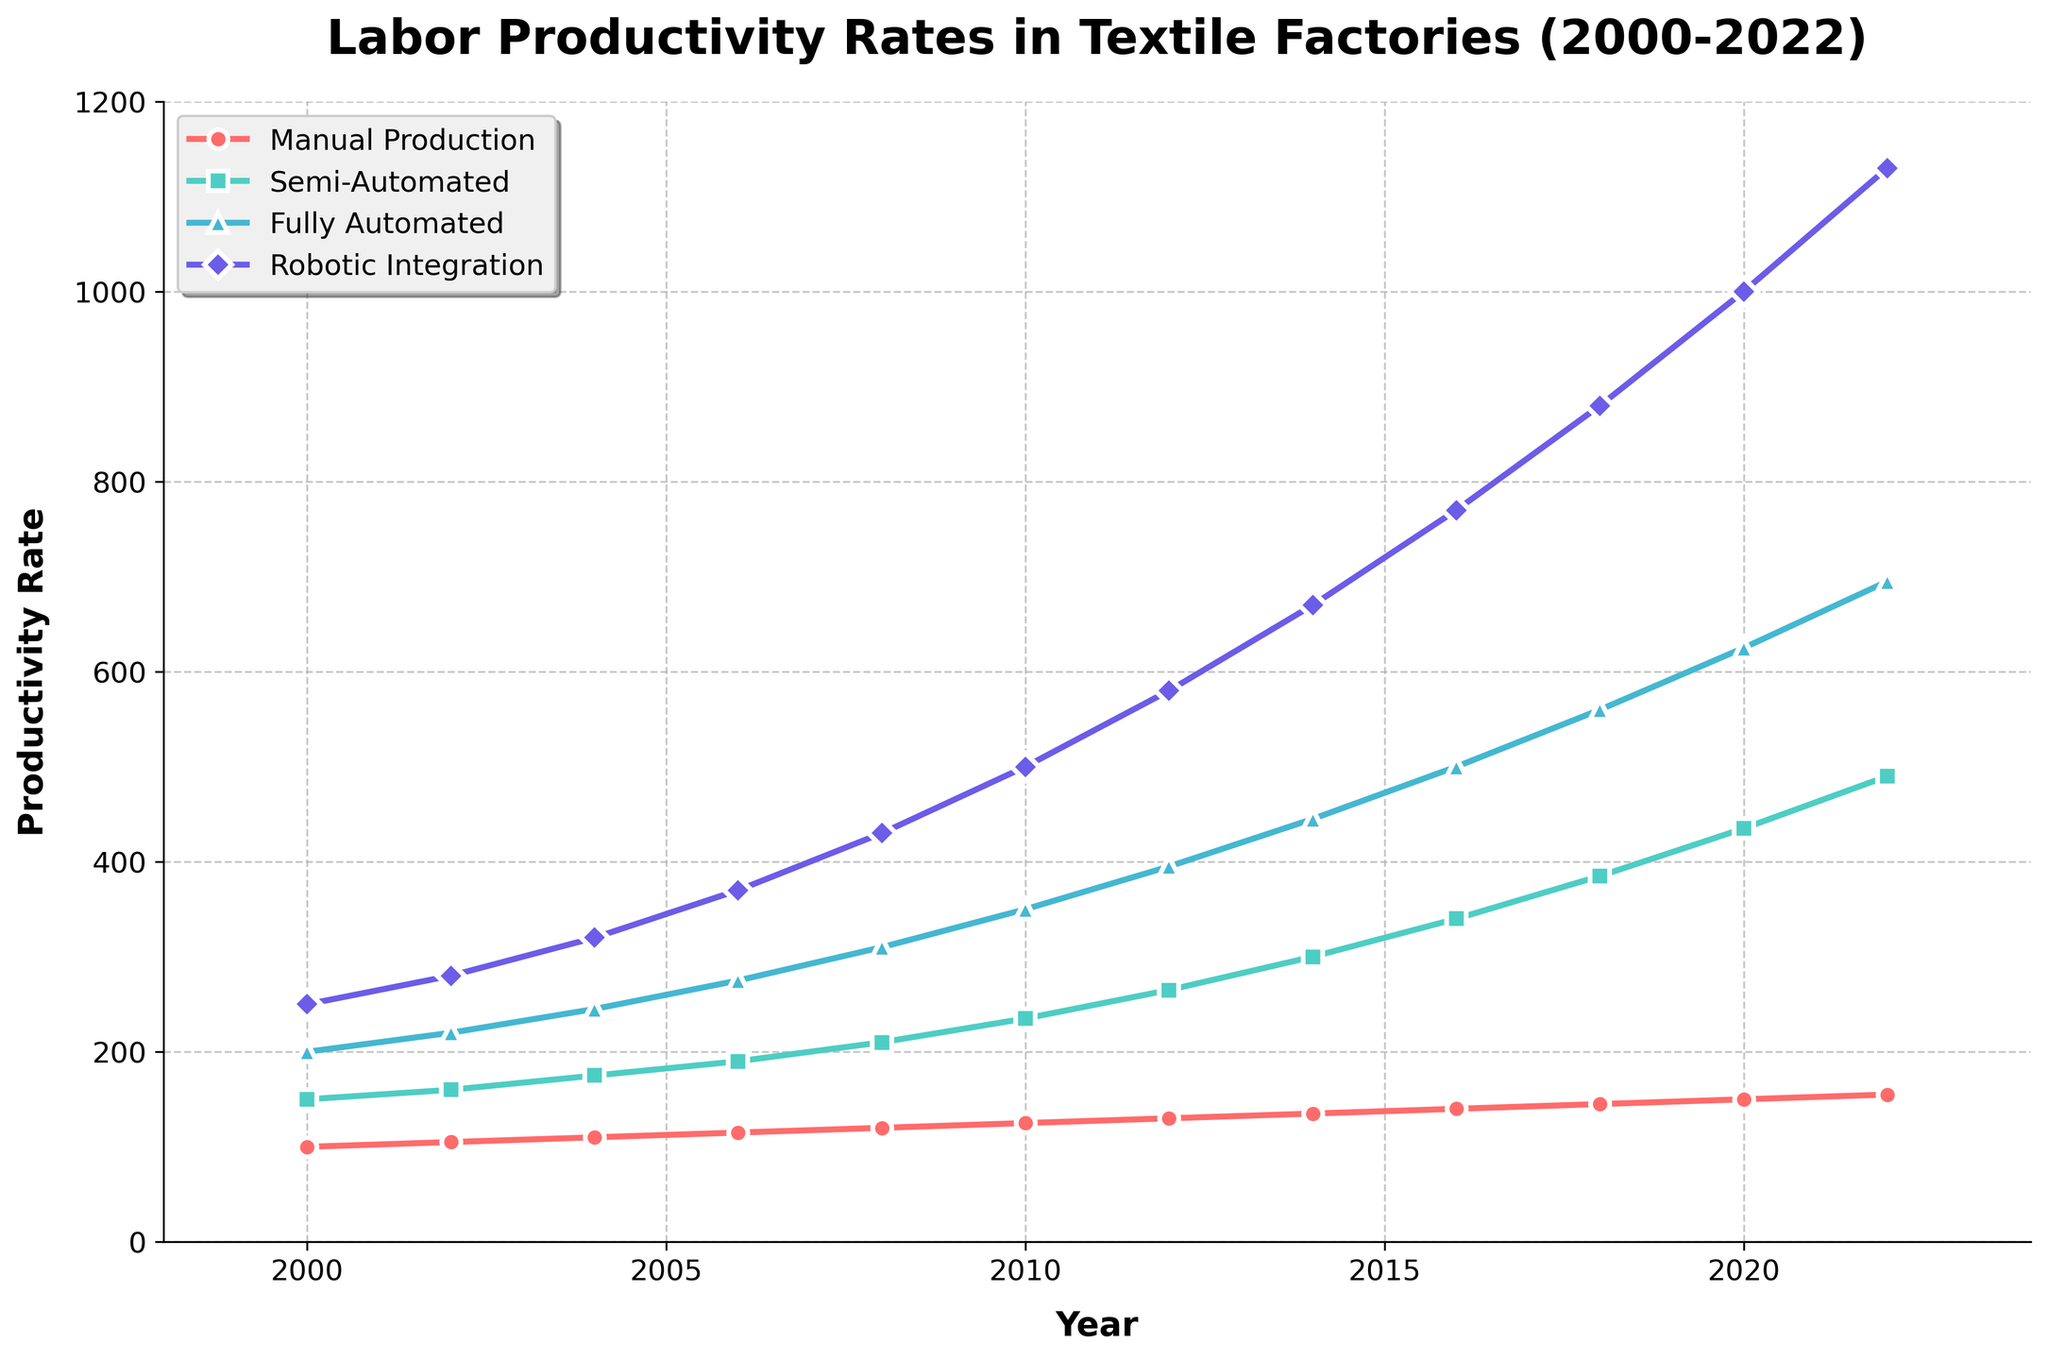What's the trend in labor productivity for Fully Automated production from 2000 to 2022? The data shows an increasing trend for Fully Automated production from 200 to 695 over the years 2000 to 2022. Each data point is higher than the previous one, indicating a continuous rise in productivity.
Answer: Increasing Which level of automation had the highest increase in productivity rate from 2000 to 2022? By comparing the productivity rates: Manual Production increased by 55 (155-100), Semi-Automated by 340 (490-150), Fully Automated by 495 (695-200), and Robotic Integration by 880 (1130-250). The highest is Robotic Integration with a 880 unit increase.
Answer: Robotic Integration What was the productivity rate for Semi-Automated production in 2010? Observing the Semi-Automated line on the chart, the productivity rate in 2010 is marked at 235.
Answer: 235 In which year did Robotic Integration surpass the 1000 productivity rate? Noticing the year when the Robotic Integration line crosses the 1000 mark on the y-axis, it happens in 2020.
Answer: 2020 Between which years did Manual Production increase by 10 units? Observing Manual Production: it increases from 105 in 2002 to 115 in 2006, and again from 125 in 2010 to 135 in 2014. However, the first 10 unit increase occurs between 2002 to 2006.
Answer: 2002 to 2006 How many years did it take for Fully Automated production to double its productivity from 2000? Fully Automated started at 200 in 2000. It doubled to 400 in 2012 (end of 2011 would already be considered). So it takes 12 years.
Answer: 12 Compare the productivity rates of Semi-Automated and Fully Automated production in 2018. In 2018, Semi-Automated production is at 385, while Fully Automated production is at 560. Fully Automated production is higher by 175 units.
Answer: Fully Automated is higher by 175 units What is the average productivity rate of Robotic Integration over the period? Adding the productivity rates of Robotic Integration from 2000-2022: (250+280+320+370+430+500+580+670+770+880+1000+1130) = 7180. Dividing by 12 (number of years) gives 598.33.
Answer: 598.33 Which level of automation had the smallest productivity gain from 2016 to 2022? Comparing the gains: Manual Production (155-140) = 15 units, Semi-Automated (490-340) = 150 units, Fully Automated (695-500) = 195 units, Robotic Integration (1130-770) = 360 units. Manual Production had the smallest gain of 15 units.
Answer: Manual Production 